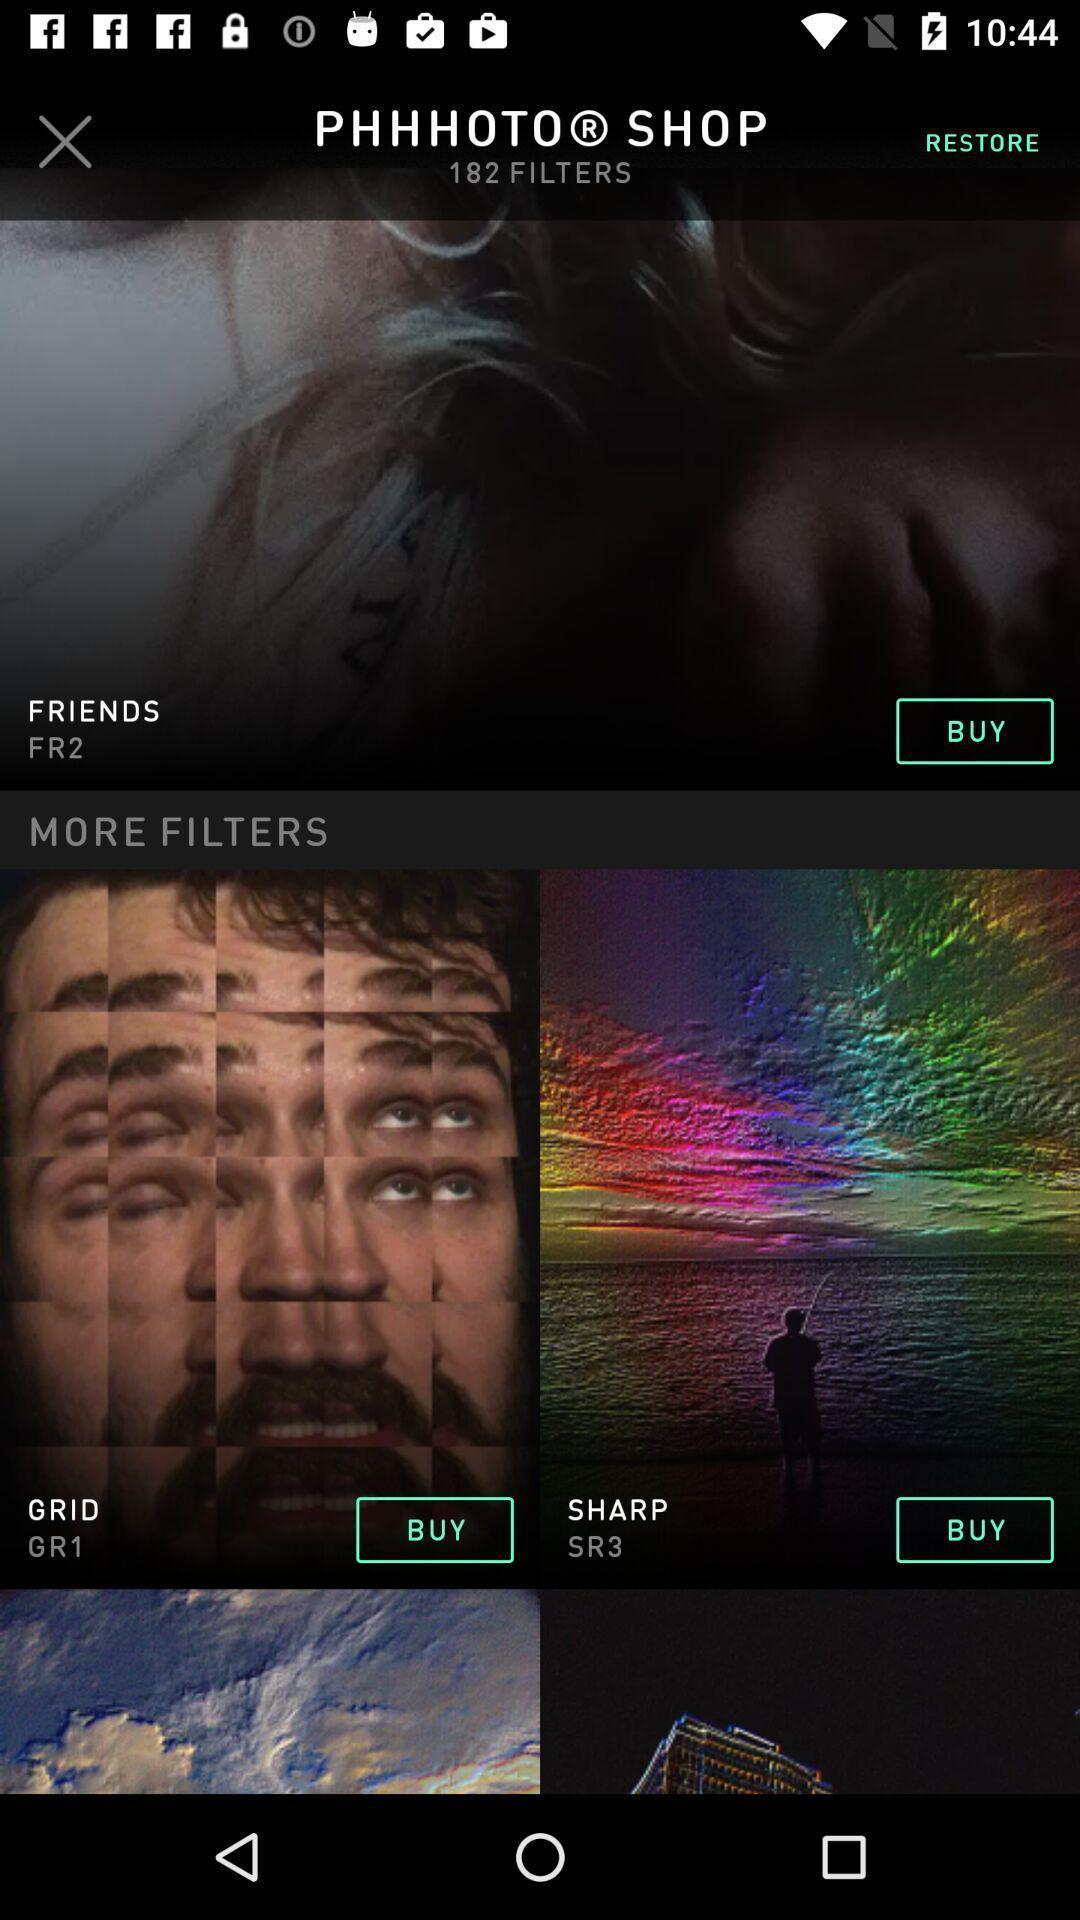Explain what's happening in this screen capture. Screen shows to purchase apps. 